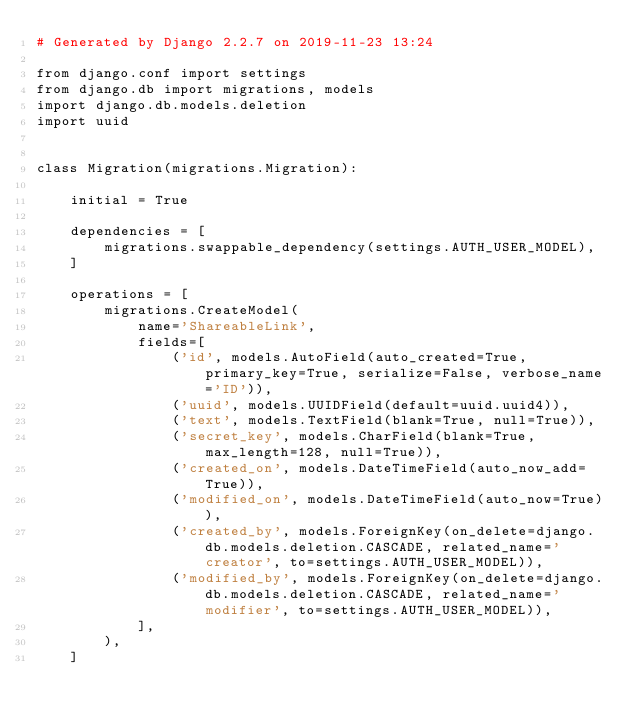<code> <loc_0><loc_0><loc_500><loc_500><_Python_># Generated by Django 2.2.7 on 2019-11-23 13:24

from django.conf import settings
from django.db import migrations, models
import django.db.models.deletion
import uuid


class Migration(migrations.Migration):

    initial = True

    dependencies = [
        migrations.swappable_dependency(settings.AUTH_USER_MODEL),
    ]

    operations = [
        migrations.CreateModel(
            name='ShareableLink',
            fields=[
                ('id', models.AutoField(auto_created=True, primary_key=True, serialize=False, verbose_name='ID')),
                ('uuid', models.UUIDField(default=uuid.uuid4)),
                ('text', models.TextField(blank=True, null=True)),
                ('secret_key', models.CharField(blank=True, max_length=128, null=True)),
                ('created_on', models.DateTimeField(auto_now_add=True)),
                ('modified_on', models.DateTimeField(auto_now=True)),
                ('created_by', models.ForeignKey(on_delete=django.db.models.deletion.CASCADE, related_name='creator', to=settings.AUTH_USER_MODEL)),
                ('modified_by', models.ForeignKey(on_delete=django.db.models.deletion.CASCADE, related_name='modifier', to=settings.AUTH_USER_MODEL)),
            ],
        ),
    ]
</code> 